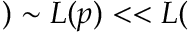<formula> <loc_0><loc_0><loc_500><loc_500>) \sim L ( p ) < < L (</formula> 